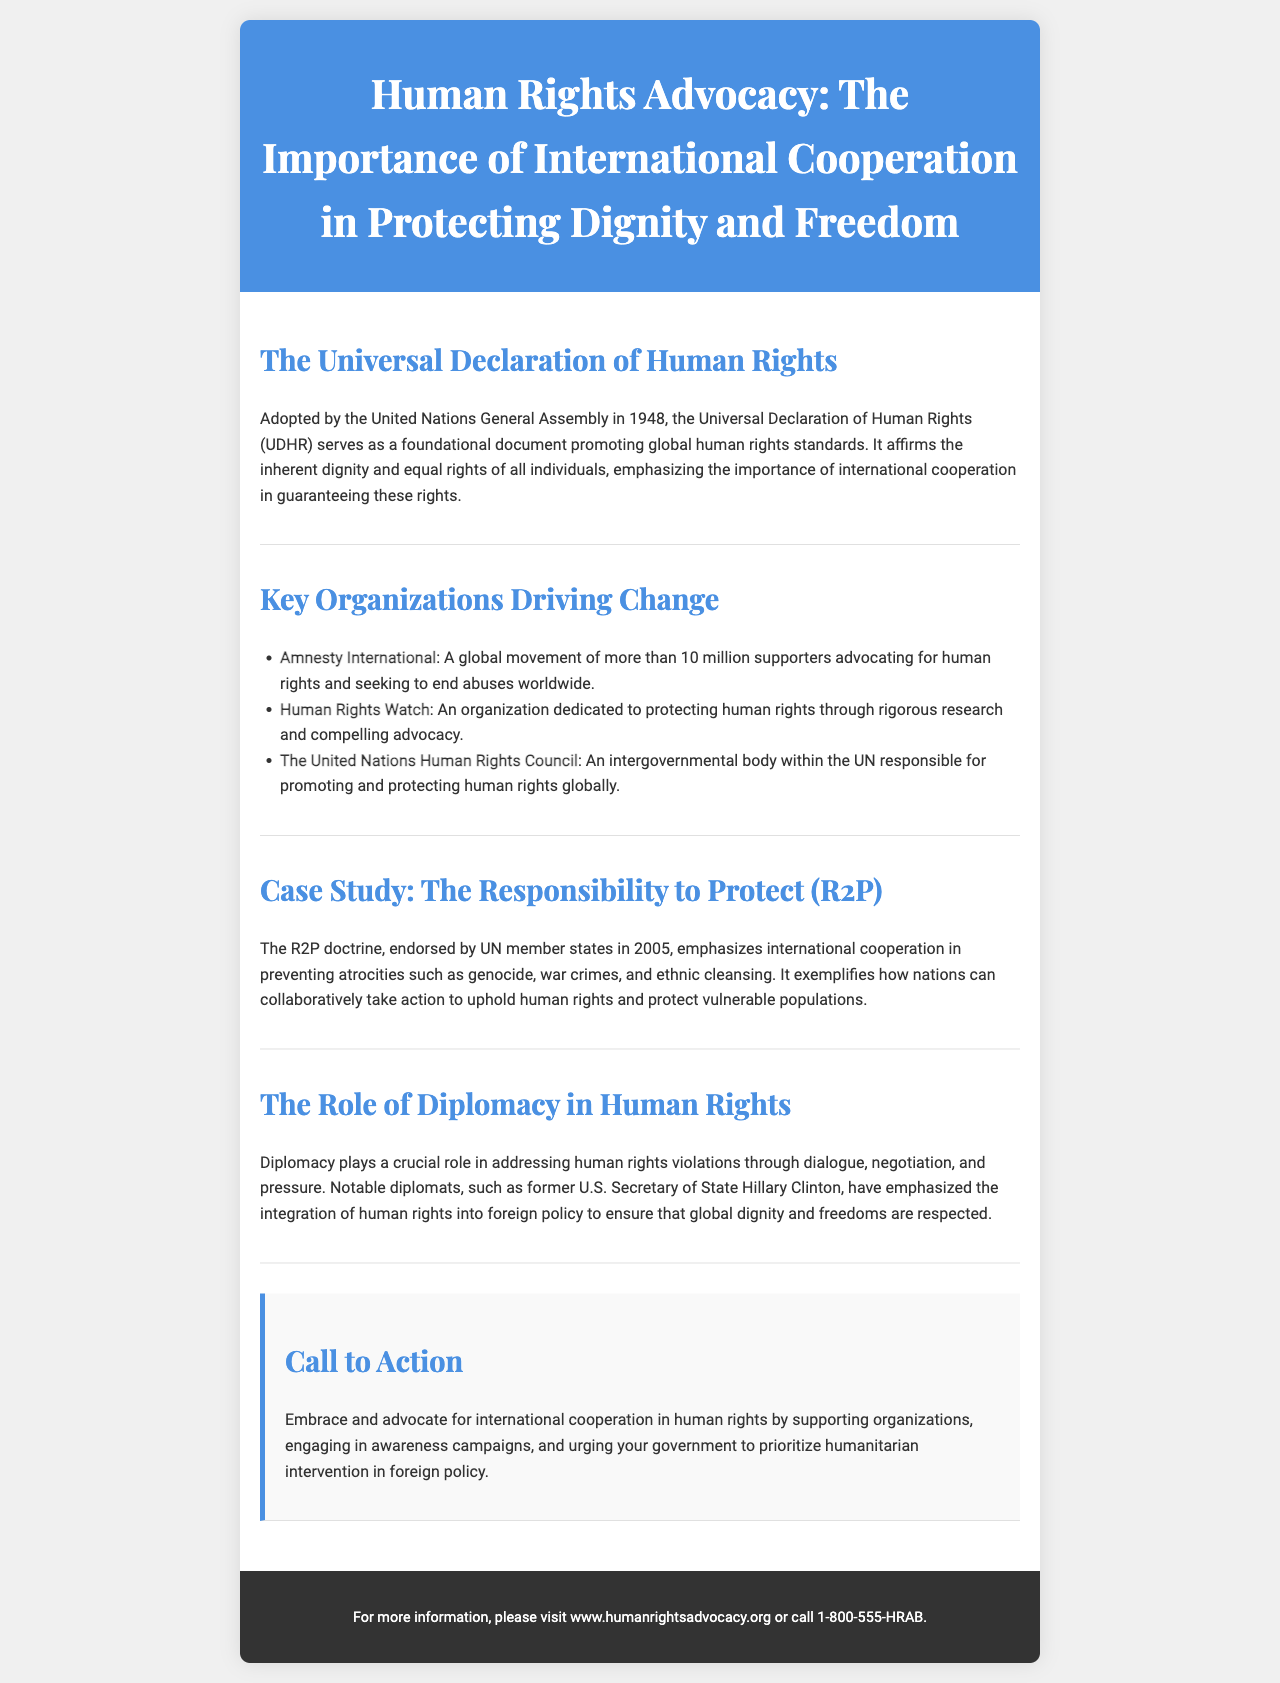What year was the Universal Declaration of Human Rights adopted? The document states that the UDHR was adopted in 1948.
Answer: 1948 What organization has more than 10 million supporters? The brochure mentions Amnesty International as a global movement of over 10 million supporters.
Answer: Amnesty International What is the focus of the Responsibility to Protect doctrine? The document describes R2P as emphasizing international cooperation in preventing atrocities such as genocide, war crimes, and ethnic cleansing.
Answer: Atrocities Who is a notable diplomat mentioned in the brochure? The document highlights former U.S. Secretary of State Hillary Clinton as a notable diplomat.
Answer: Hillary Clinton What does the call to action encourage individuals to do? The call to action encourages advocacy for international cooperation in human rights and support for organizations.
Answer: Advocate for international cooperation 